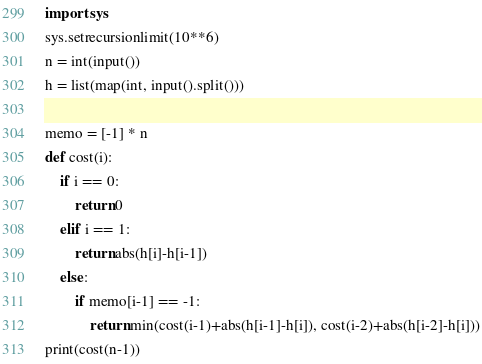<code> <loc_0><loc_0><loc_500><loc_500><_Python_>import sys
sys.setrecursionlimit(10**6)
n = int(input())
h = list(map(int, input().split()))

memo = [-1] * n
def cost(i):
    if i == 0:
        return 0
    elif i == 1:
        return abs(h[i]-h[i-1])
    else:
        if memo[i-1] == -1:
            return min(cost(i-1)+abs(h[i-1]-h[i]), cost(i-2)+abs(h[i-2]-h[i]))
print(cost(n-1))</code> 